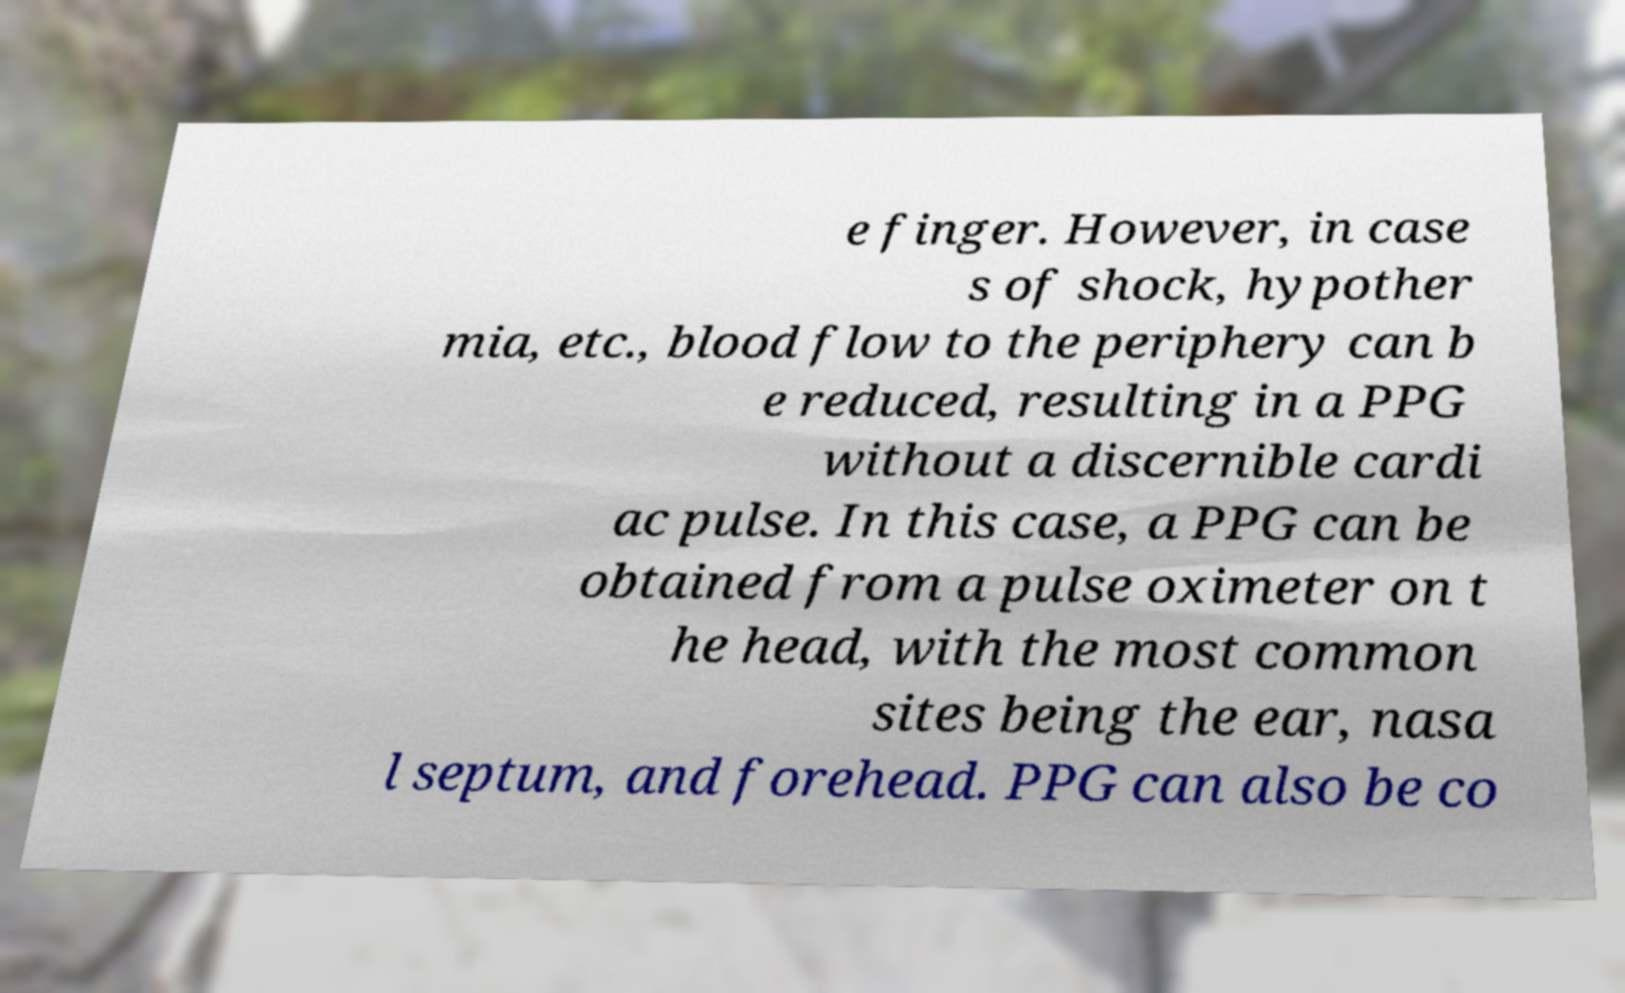Could you extract and type out the text from this image? e finger. However, in case s of shock, hypother mia, etc., blood flow to the periphery can b e reduced, resulting in a PPG without a discernible cardi ac pulse. In this case, a PPG can be obtained from a pulse oximeter on t he head, with the most common sites being the ear, nasa l septum, and forehead. PPG can also be co 